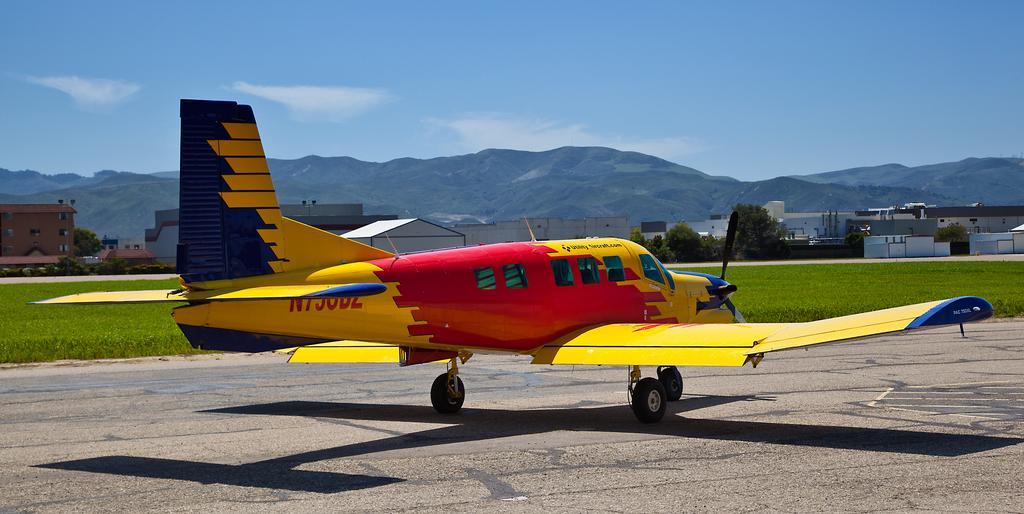Describe this image in one or two sentences. In the foreground of the picture I can see an airplane on the road. I can see the green grass in the picture. In the background, I can see the houses and mountains. There are clouds in the sky. 